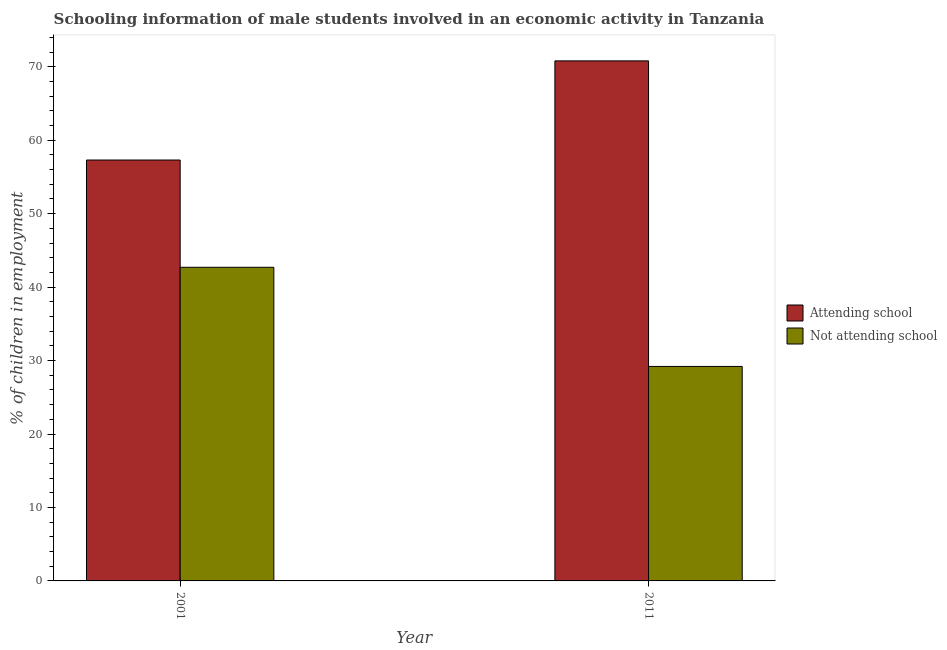How many different coloured bars are there?
Your response must be concise. 2. How many groups of bars are there?
Ensure brevity in your answer.  2. Are the number of bars on each tick of the X-axis equal?
Your response must be concise. Yes. What is the label of the 1st group of bars from the left?
Provide a short and direct response. 2001. In how many cases, is the number of bars for a given year not equal to the number of legend labels?
Keep it short and to the point. 0. What is the percentage of employed males who are not attending school in 2001?
Offer a terse response. 42.7. Across all years, what is the maximum percentage of employed males who are not attending school?
Your response must be concise. 42.7. Across all years, what is the minimum percentage of employed males who are attending school?
Your answer should be compact. 57.3. In which year was the percentage of employed males who are not attending school maximum?
Provide a succinct answer. 2001. In which year was the percentage of employed males who are not attending school minimum?
Keep it short and to the point. 2011. What is the total percentage of employed males who are attending school in the graph?
Ensure brevity in your answer.  128.1. What is the difference between the percentage of employed males who are not attending school in 2001 and that in 2011?
Your answer should be very brief. 13.5. What is the difference between the percentage of employed males who are attending school in 2011 and the percentage of employed males who are not attending school in 2001?
Provide a succinct answer. 13.5. What is the average percentage of employed males who are attending school per year?
Your response must be concise. 64.05. In the year 2001, what is the difference between the percentage of employed males who are not attending school and percentage of employed males who are attending school?
Offer a terse response. 0. What is the ratio of the percentage of employed males who are not attending school in 2001 to that in 2011?
Make the answer very short. 1.46. In how many years, is the percentage of employed males who are attending school greater than the average percentage of employed males who are attending school taken over all years?
Your answer should be compact. 1. What does the 1st bar from the left in 2011 represents?
Ensure brevity in your answer.  Attending school. What does the 2nd bar from the right in 2001 represents?
Give a very brief answer. Attending school. Are all the bars in the graph horizontal?
Provide a succinct answer. No. Are the values on the major ticks of Y-axis written in scientific E-notation?
Offer a very short reply. No. Does the graph contain any zero values?
Offer a terse response. No. Does the graph contain grids?
Provide a short and direct response. No. How are the legend labels stacked?
Your answer should be compact. Vertical. What is the title of the graph?
Provide a succinct answer. Schooling information of male students involved in an economic activity in Tanzania. What is the label or title of the Y-axis?
Offer a terse response. % of children in employment. What is the % of children in employment in Attending school in 2001?
Offer a terse response. 57.3. What is the % of children in employment of Not attending school in 2001?
Make the answer very short. 42.7. What is the % of children in employment in Attending school in 2011?
Offer a terse response. 70.8. What is the % of children in employment in Not attending school in 2011?
Provide a short and direct response. 29.2. Across all years, what is the maximum % of children in employment of Attending school?
Keep it short and to the point. 70.8. Across all years, what is the maximum % of children in employment of Not attending school?
Provide a short and direct response. 42.7. Across all years, what is the minimum % of children in employment in Attending school?
Ensure brevity in your answer.  57.3. Across all years, what is the minimum % of children in employment in Not attending school?
Your answer should be very brief. 29.2. What is the total % of children in employment in Attending school in the graph?
Offer a very short reply. 128.1. What is the total % of children in employment of Not attending school in the graph?
Offer a terse response. 71.9. What is the difference between the % of children in employment in Attending school in 2001 and that in 2011?
Provide a short and direct response. -13.5. What is the difference between the % of children in employment of Not attending school in 2001 and that in 2011?
Give a very brief answer. 13.5. What is the difference between the % of children in employment of Attending school in 2001 and the % of children in employment of Not attending school in 2011?
Your answer should be very brief. 28.1. What is the average % of children in employment in Attending school per year?
Provide a short and direct response. 64.05. What is the average % of children in employment in Not attending school per year?
Keep it short and to the point. 35.95. In the year 2001, what is the difference between the % of children in employment of Attending school and % of children in employment of Not attending school?
Keep it short and to the point. 14.6. In the year 2011, what is the difference between the % of children in employment in Attending school and % of children in employment in Not attending school?
Offer a terse response. 41.6. What is the ratio of the % of children in employment in Attending school in 2001 to that in 2011?
Offer a terse response. 0.81. What is the ratio of the % of children in employment in Not attending school in 2001 to that in 2011?
Keep it short and to the point. 1.46. What is the difference between the highest and the second highest % of children in employment in Attending school?
Keep it short and to the point. 13.5. What is the difference between the highest and the second highest % of children in employment of Not attending school?
Provide a succinct answer. 13.5. What is the difference between the highest and the lowest % of children in employment of Attending school?
Keep it short and to the point. 13.5. What is the difference between the highest and the lowest % of children in employment of Not attending school?
Offer a very short reply. 13.5. 